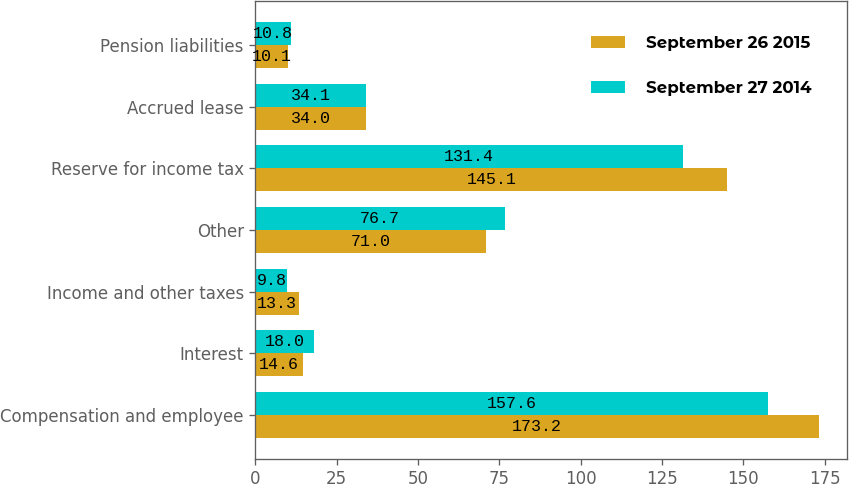Convert chart to OTSL. <chart><loc_0><loc_0><loc_500><loc_500><stacked_bar_chart><ecel><fcel>Compensation and employee<fcel>Interest<fcel>Income and other taxes<fcel>Other<fcel>Reserve for income tax<fcel>Accrued lease<fcel>Pension liabilities<nl><fcel>September 26 2015<fcel>173.2<fcel>14.6<fcel>13.3<fcel>71<fcel>145.1<fcel>34<fcel>10.1<nl><fcel>September 27 2014<fcel>157.6<fcel>18<fcel>9.8<fcel>76.7<fcel>131.4<fcel>34.1<fcel>10.8<nl></chart> 